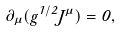<formula> <loc_0><loc_0><loc_500><loc_500>\partial _ { \mu } ( g ^ { 1 / 2 } J ^ { \mu } ) = 0 ,</formula> 